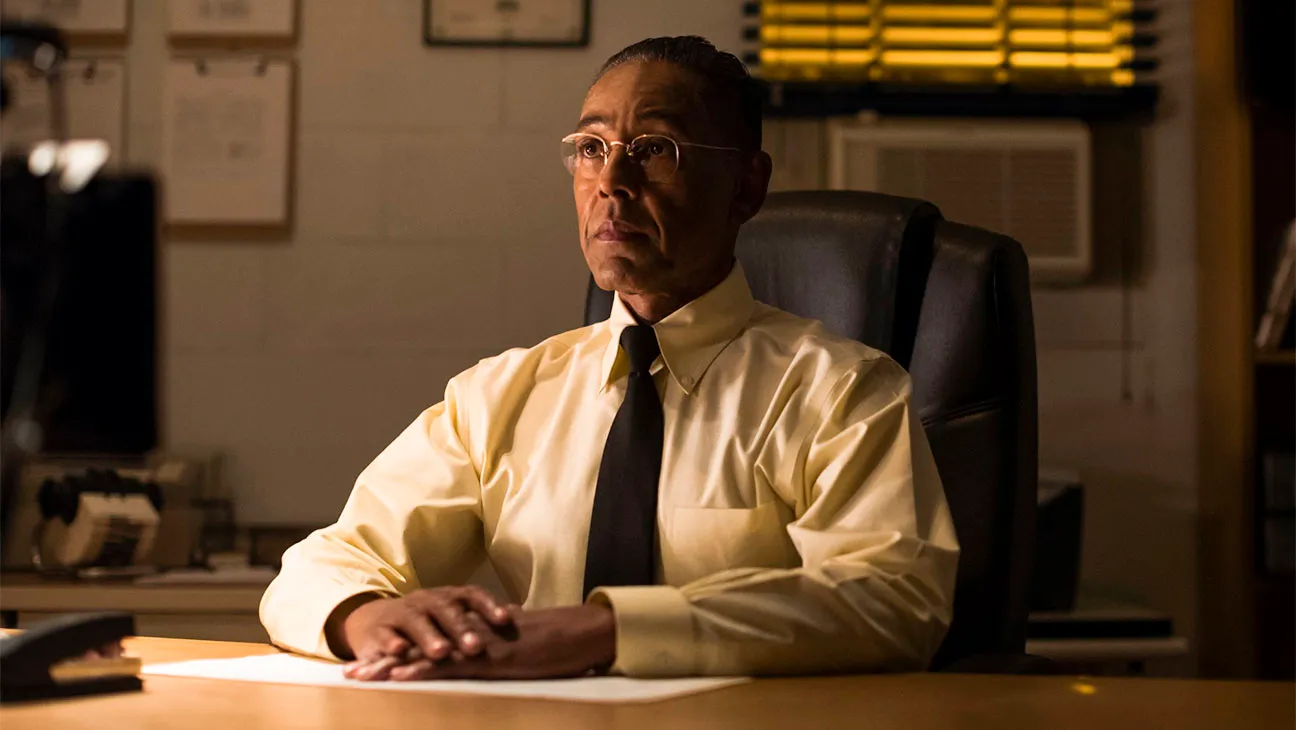Explain the visual content of the image in great detail. In the image, we see the notable actor, known for portraying Gus Fring in the acclaimed TV series Breaking Bad. He is seated at a desk in what appears to be an office or a formal setting. He is dressed in a light yellow dress shirt with a black tie, his demeanor serious and composed as he looks off to the side. The lighting in the room is dim, casting a somber tone over the scene, with yellow Venetian blinds covering a window behind him, allowing slivers of light to peek through. On the desk, there are some documents and objects partially visible, suggesting that he might be in the middle of some important work or deep in thought about something significant. 